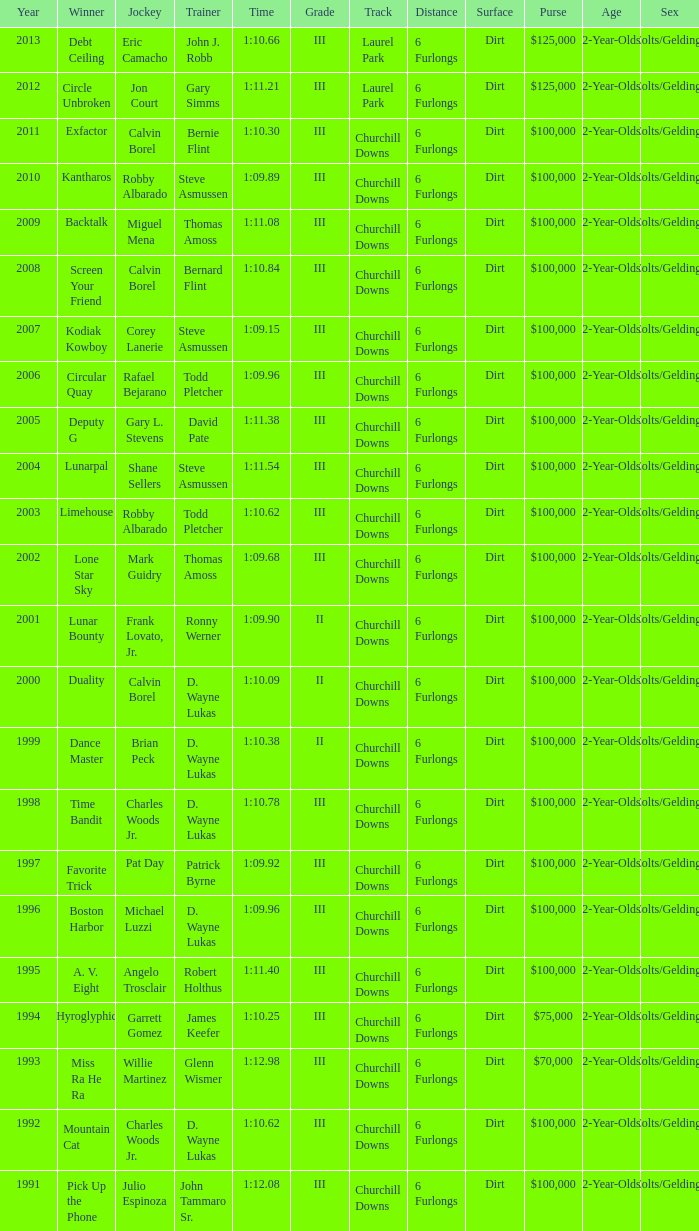Which coach achieved a time of 1:10.09 in a year prior to 2009? D. Wayne Lukas. 